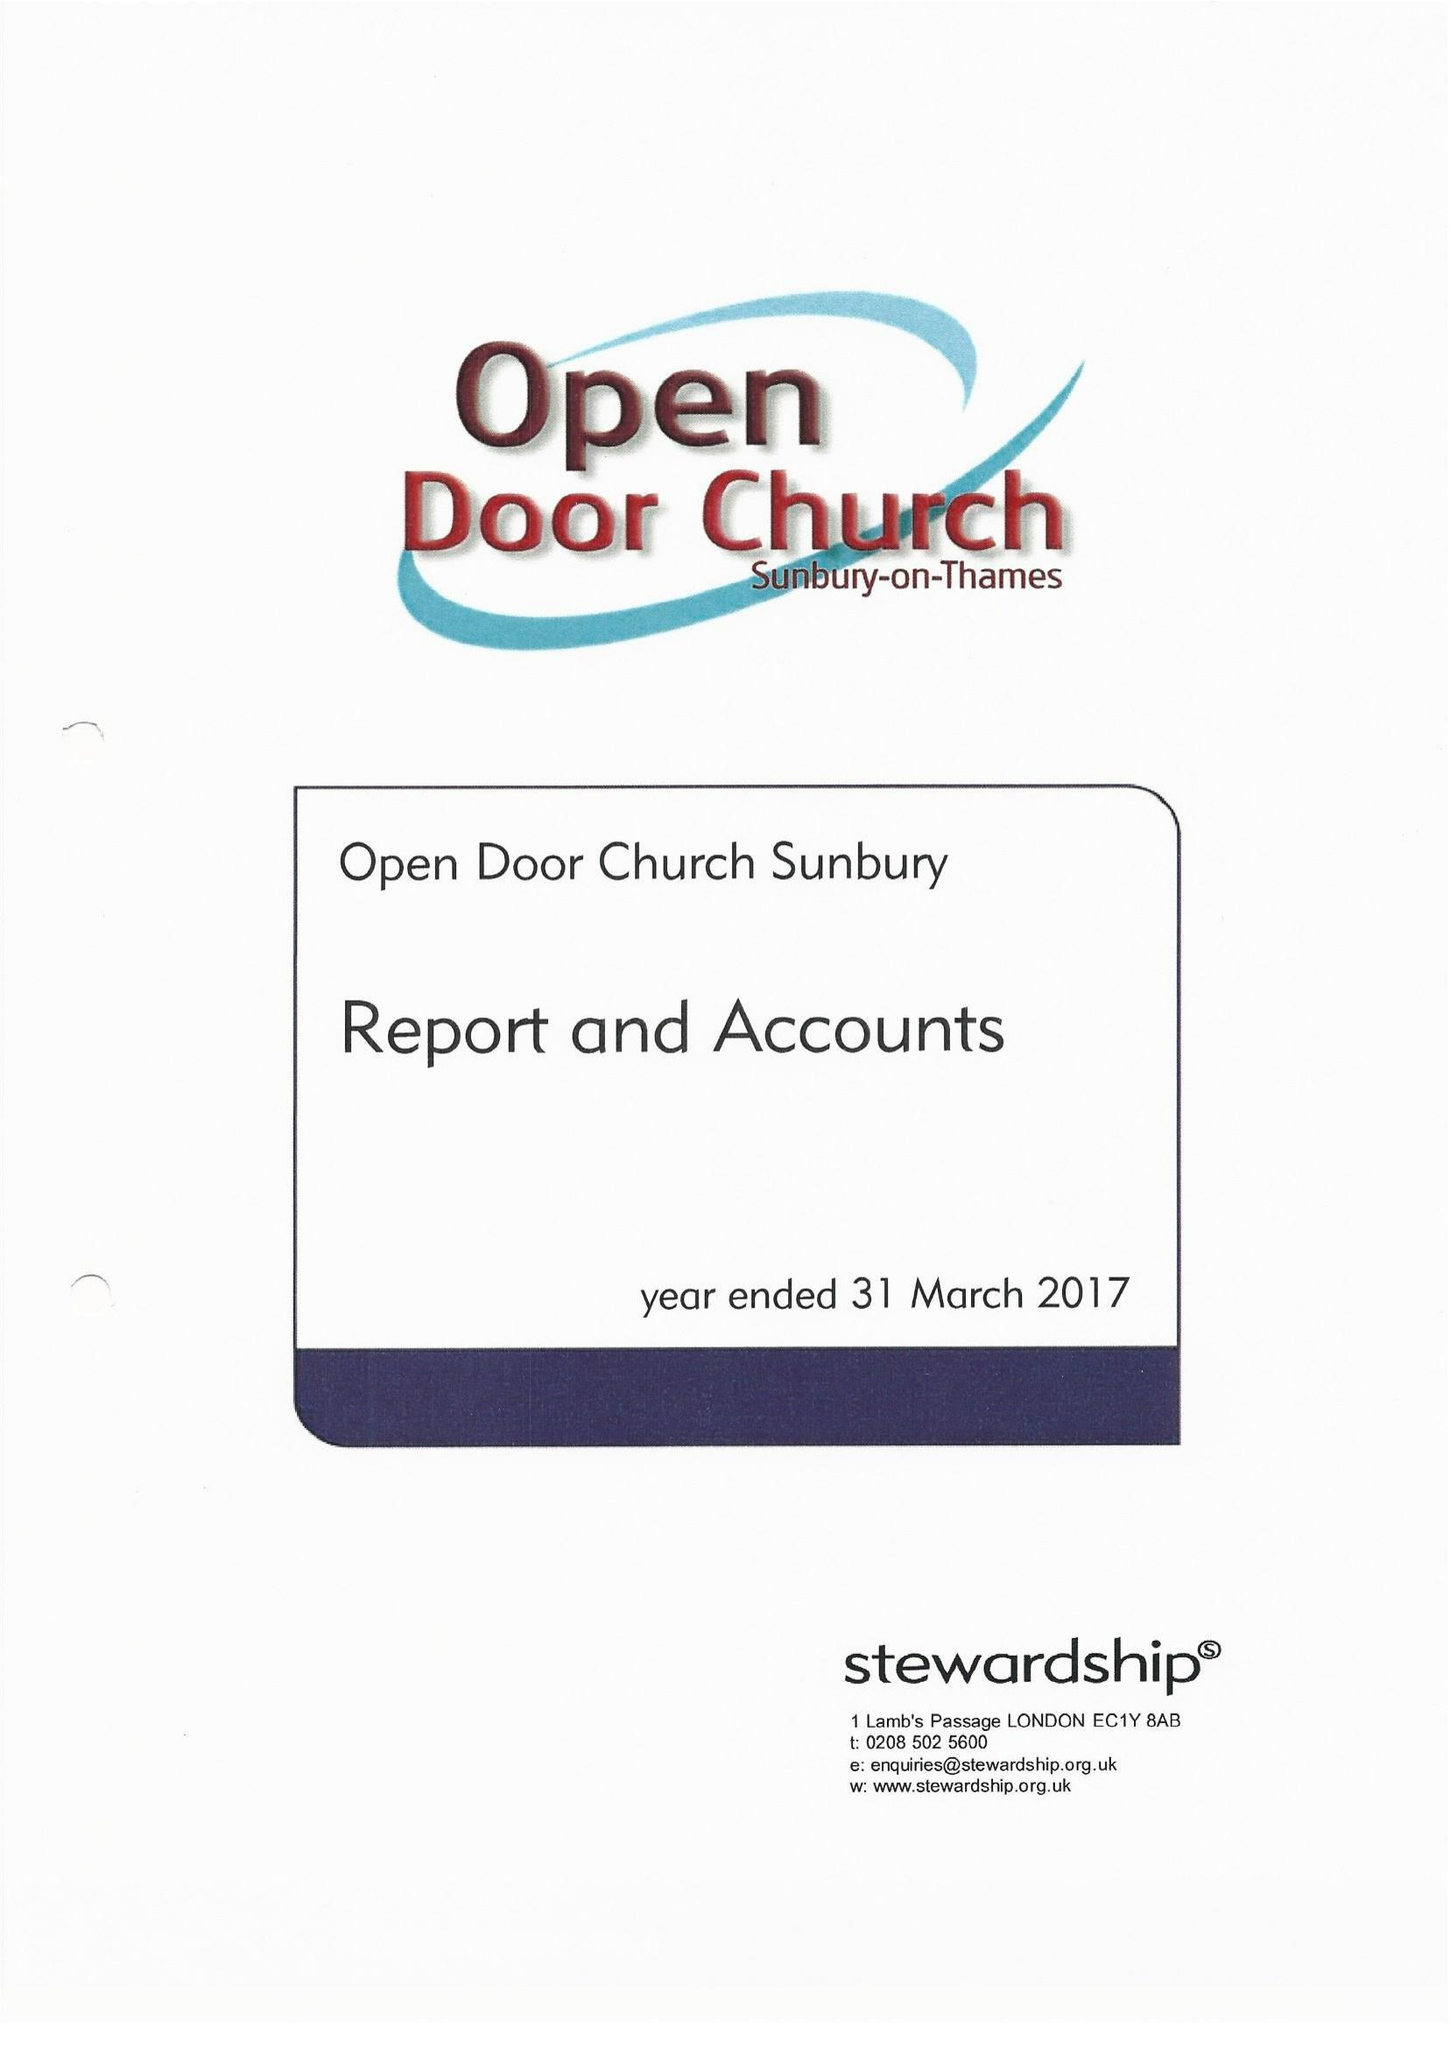What is the value for the spending_annually_in_british_pounds?
Answer the question using a single word or phrase. 170253.00 